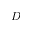Convert formula to latex. <formula><loc_0><loc_0><loc_500><loc_500>D</formula> 